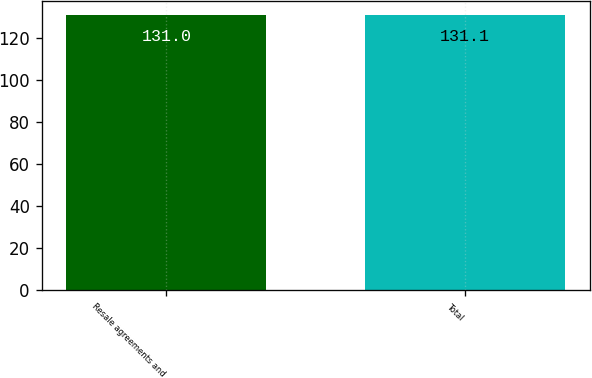Convert chart. <chart><loc_0><loc_0><loc_500><loc_500><bar_chart><fcel>Resale agreements and<fcel>Total<nl><fcel>131<fcel>131.1<nl></chart> 